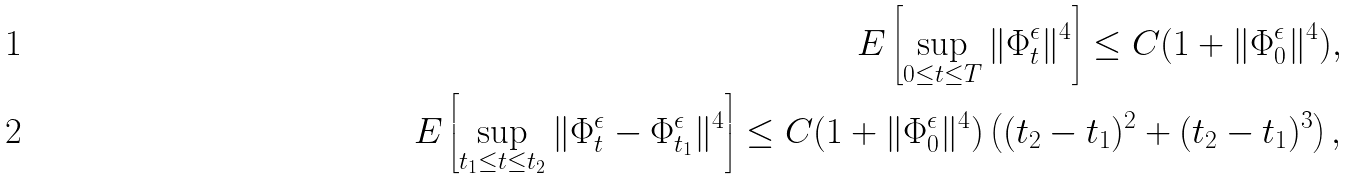Convert formula to latex. <formula><loc_0><loc_0><loc_500><loc_500>E \left [ \sup _ { 0 \leq t \leq T } \| \Phi _ { t } ^ { \epsilon } \| ^ { 4 } \right ] \leq C ( 1 + \| \Phi _ { 0 } ^ { \epsilon } \| ^ { 4 } ) , \\ E \left [ \sup _ { t _ { 1 } \leq t \leq t _ { 2 } } \| \Phi _ { t } ^ { \epsilon } - \Phi _ { t _ { 1 } } ^ { \epsilon } \| ^ { 4 } \right ] \leq C ( 1 + \| \Phi _ { 0 } ^ { \epsilon } \| ^ { 4 } ) \left ( ( t _ { 2 } - t _ { 1 } ) ^ { 2 } + ( t _ { 2 } - t _ { 1 } ) ^ { 3 } \right ) ,</formula> 